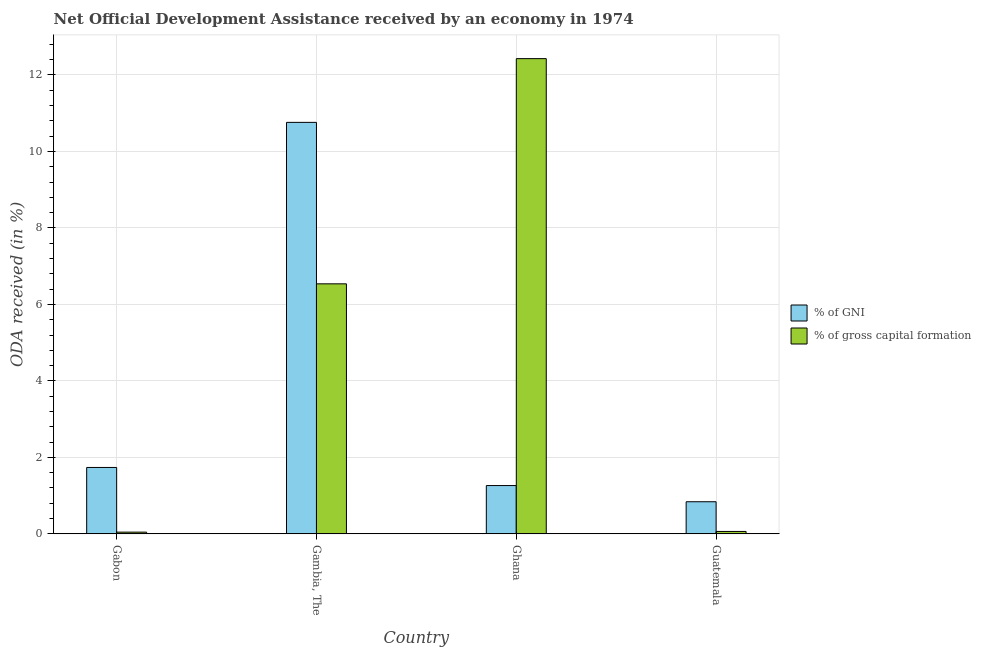What is the label of the 4th group of bars from the left?
Offer a terse response. Guatemala. In how many cases, is the number of bars for a given country not equal to the number of legend labels?
Offer a very short reply. 0. What is the oda received as percentage of gross capital formation in Gabon?
Keep it short and to the point. 0.05. Across all countries, what is the maximum oda received as percentage of gni?
Your answer should be compact. 10.76. Across all countries, what is the minimum oda received as percentage of gross capital formation?
Offer a very short reply. 0.05. In which country was the oda received as percentage of gross capital formation minimum?
Provide a succinct answer. Gabon. What is the total oda received as percentage of gross capital formation in the graph?
Provide a short and direct response. 19.07. What is the difference between the oda received as percentage of gni in Gabon and that in Guatemala?
Provide a short and direct response. 0.9. What is the difference between the oda received as percentage of gross capital formation in Gambia, The and the oda received as percentage of gni in Gabon?
Keep it short and to the point. 4.8. What is the average oda received as percentage of gni per country?
Make the answer very short. 3.65. What is the difference between the oda received as percentage of gross capital formation and oda received as percentage of gni in Gambia, The?
Provide a succinct answer. -4.22. In how many countries, is the oda received as percentage of gross capital formation greater than 4.4 %?
Ensure brevity in your answer.  2. What is the ratio of the oda received as percentage of gni in Gambia, The to that in Guatemala?
Give a very brief answer. 12.81. Is the oda received as percentage of gross capital formation in Gambia, The less than that in Guatemala?
Your answer should be very brief. No. Is the difference between the oda received as percentage of gni in Ghana and Guatemala greater than the difference between the oda received as percentage of gross capital formation in Ghana and Guatemala?
Offer a very short reply. No. What is the difference between the highest and the second highest oda received as percentage of gni?
Your answer should be very brief. 9.02. What is the difference between the highest and the lowest oda received as percentage of gni?
Offer a terse response. 9.92. What does the 1st bar from the left in Guatemala represents?
Provide a short and direct response. % of GNI. What does the 1st bar from the right in Guatemala represents?
Your answer should be compact. % of gross capital formation. Are all the bars in the graph horizontal?
Your response must be concise. No. What is the difference between two consecutive major ticks on the Y-axis?
Offer a very short reply. 2. How are the legend labels stacked?
Your answer should be very brief. Vertical. What is the title of the graph?
Make the answer very short. Net Official Development Assistance received by an economy in 1974. What is the label or title of the Y-axis?
Ensure brevity in your answer.  ODA received (in %). What is the ODA received (in %) of % of GNI in Gabon?
Make the answer very short. 1.74. What is the ODA received (in %) in % of gross capital formation in Gabon?
Offer a terse response. 0.05. What is the ODA received (in %) of % of GNI in Gambia, The?
Provide a short and direct response. 10.76. What is the ODA received (in %) in % of gross capital formation in Gambia, The?
Keep it short and to the point. 6.54. What is the ODA received (in %) of % of GNI in Ghana?
Provide a short and direct response. 1.26. What is the ODA received (in %) in % of gross capital formation in Ghana?
Give a very brief answer. 12.43. What is the ODA received (in %) in % of GNI in Guatemala?
Your answer should be very brief. 0.84. What is the ODA received (in %) in % of gross capital formation in Guatemala?
Your answer should be compact. 0.06. Across all countries, what is the maximum ODA received (in %) in % of GNI?
Make the answer very short. 10.76. Across all countries, what is the maximum ODA received (in %) in % of gross capital formation?
Your response must be concise. 12.43. Across all countries, what is the minimum ODA received (in %) of % of GNI?
Keep it short and to the point. 0.84. Across all countries, what is the minimum ODA received (in %) of % of gross capital formation?
Your answer should be very brief. 0.05. What is the total ODA received (in %) of % of GNI in the graph?
Your answer should be compact. 14.6. What is the total ODA received (in %) of % of gross capital formation in the graph?
Offer a very short reply. 19.07. What is the difference between the ODA received (in %) in % of GNI in Gabon and that in Gambia, The?
Give a very brief answer. -9.02. What is the difference between the ODA received (in %) in % of gross capital formation in Gabon and that in Gambia, The?
Your answer should be very brief. -6.49. What is the difference between the ODA received (in %) in % of GNI in Gabon and that in Ghana?
Ensure brevity in your answer.  0.47. What is the difference between the ODA received (in %) of % of gross capital formation in Gabon and that in Ghana?
Offer a terse response. -12.38. What is the difference between the ODA received (in %) of % of GNI in Gabon and that in Guatemala?
Offer a terse response. 0.9. What is the difference between the ODA received (in %) in % of gross capital formation in Gabon and that in Guatemala?
Provide a short and direct response. -0.02. What is the difference between the ODA received (in %) of % of GNI in Gambia, The and that in Ghana?
Give a very brief answer. 9.5. What is the difference between the ODA received (in %) of % of gross capital formation in Gambia, The and that in Ghana?
Your response must be concise. -5.89. What is the difference between the ODA received (in %) in % of GNI in Gambia, The and that in Guatemala?
Offer a terse response. 9.92. What is the difference between the ODA received (in %) in % of gross capital formation in Gambia, The and that in Guatemala?
Your answer should be very brief. 6.47. What is the difference between the ODA received (in %) of % of GNI in Ghana and that in Guatemala?
Keep it short and to the point. 0.42. What is the difference between the ODA received (in %) of % of gross capital formation in Ghana and that in Guatemala?
Your response must be concise. 12.36. What is the difference between the ODA received (in %) in % of GNI in Gabon and the ODA received (in %) in % of gross capital formation in Gambia, The?
Make the answer very short. -4.8. What is the difference between the ODA received (in %) in % of GNI in Gabon and the ODA received (in %) in % of gross capital formation in Ghana?
Your answer should be compact. -10.69. What is the difference between the ODA received (in %) of % of GNI in Gabon and the ODA received (in %) of % of gross capital formation in Guatemala?
Offer a terse response. 1.67. What is the difference between the ODA received (in %) in % of GNI in Gambia, The and the ODA received (in %) in % of gross capital formation in Ghana?
Provide a short and direct response. -1.67. What is the difference between the ODA received (in %) of % of GNI in Gambia, The and the ODA received (in %) of % of gross capital formation in Guatemala?
Keep it short and to the point. 10.7. What is the difference between the ODA received (in %) of % of GNI in Ghana and the ODA received (in %) of % of gross capital formation in Guatemala?
Provide a succinct answer. 1.2. What is the average ODA received (in %) in % of GNI per country?
Offer a very short reply. 3.65. What is the average ODA received (in %) in % of gross capital formation per country?
Offer a terse response. 4.77. What is the difference between the ODA received (in %) of % of GNI and ODA received (in %) of % of gross capital formation in Gabon?
Provide a succinct answer. 1.69. What is the difference between the ODA received (in %) in % of GNI and ODA received (in %) in % of gross capital formation in Gambia, The?
Your response must be concise. 4.22. What is the difference between the ODA received (in %) of % of GNI and ODA received (in %) of % of gross capital formation in Ghana?
Offer a terse response. -11.16. What is the difference between the ODA received (in %) in % of GNI and ODA received (in %) in % of gross capital formation in Guatemala?
Ensure brevity in your answer.  0.78. What is the ratio of the ODA received (in %) in % of GNI in Gabon to that in Gambia, The?
Make the answer very short. 0.16. What is the ratio of the ODA received (in %) in % of gross capital formation in Gabon to that in Gambia, The?
Your response must be concise. 0.01. What is the ratio of the ODA received (in %) in % of GNI in Gabon to that in Ghana?
Provide a short and direct response. 1.37. What is the ratio of the ODA received (in %) of % of gross capital formation in Gabon to that in Ghana?
Keep it short and to the point. 0. What is the ratio of the ODA received (in %) of % of GNI in Gabon to that in Guatemala?
Your response must be concise. 2.07. What is the ratio of the ODA received (in %) of % of gross capital formation in Gabon to that in Guatemala?
Your answer should be very brief. 0.72. What is the ratio of the ODA received (in %) of % of GNI in Gambia, The to that in Ghana?
Your response must be concise. 8.52. What is the ratio of the ODA received (in %) of % of gross capital formation in Gambia, The to that in Ghana?
Keep it short and to the point. 0.53. What is the ratio of the ODA received (in %) of % of GNI in Gambia, The to that in Guatemala?
Make the answer very short. 12.81. What is the ratio of the ODA received (in %) of % of gross capital formation in Gambia, The to that in Guatemala?
Provide a succinct answer. 103.24. What is the ratio of the ODA received (in %) in % of GNI in Ghana to that in Guatemala?
Make the answer very short. 1.5. What is the ratio of the ODA received (in %) of % of gross capital formation in Ghana to that in Guatemala?
Keep it short and to the point. 196.24. What is the difference between the highest and the second highest ODA received (in %) in % of GNI?
Your answer should be compact. 9.02. What is the difference between the highest and the second highest ODA received (in %) of % of gross capital formation?
Give a very brief answer. 5.89. What is the difference between the highest and the lowest ODA received (in %) in % of GNI?
Your answer should be very brief. 9.92. What is the difference between the highest and the lowest ODA received (in %) in % of gross capital formation?
Keep it short and to the point. 12.38. 